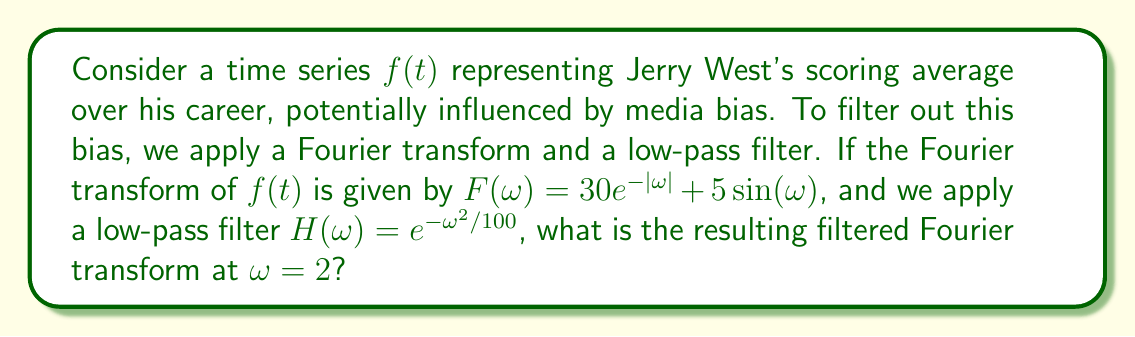Teach me how to tackle this problem. To solve this problem, we'll follow these steps:

1) The given Fourier transform of Jerry West's scoring average is:

   $$F(\omega) = 30e^{-|\omega|} + 5\sin(\omega)$$

2) The low-pass filter function is:

   $$H(\omega) = e^{-\omega^2/100}$$

3) To apply the filter, we multiply $F(\omega)$ by $H(\omega)$:

   $$F_{filtered}(\omega) = F(\omega) \cdot H(\omega)$$

4) Substituting the given functions:

   $$F_{filtered}(\omega) = (30e^{-|\omega|} + 5\sin(\omega)) \cdot e^{-\omega^2/100}$$

5) We need to evaluate this at $\omega = 2$:

   $$F_{filtered}(2) = (30e^{-|2|} + 5\sin(2)) \cdot e^{-2^2/100}$$

6) Simplifying:
   - $e^{-|2|} = e^{-2}$
   - $\sin(2) \approx 0.9093$
   - $e^{-2^2/100} = e^{-0.04} \approx 0.9608$

7) Calculating:

   $$F_{filtered}(2) = (30e^{-2} + 5 \cdot 0.9093) \cdot 0.9608$$
   $$= (30 \cdot 0.1353 + 4.5465) \cdot 0.9608$$
   $$= (4.059 + 4.5465) \cdot 0.9608$$
   $$= 8.6055 \cdot 0.9608$$
   $$\approx 8.2680$$

This result represents Jerry West's filtered scoring average at frequency $\omega = 2$, with media bias potentially reduced.
Answer: $F_{filtered}(2) \approx 8.2680$ 